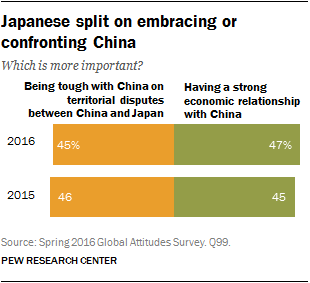Specify some key components in this picture. The color of the 47% bar is green. The average value between 2019 and 2015 was a strong relationship with China, with a value of 0.46. 